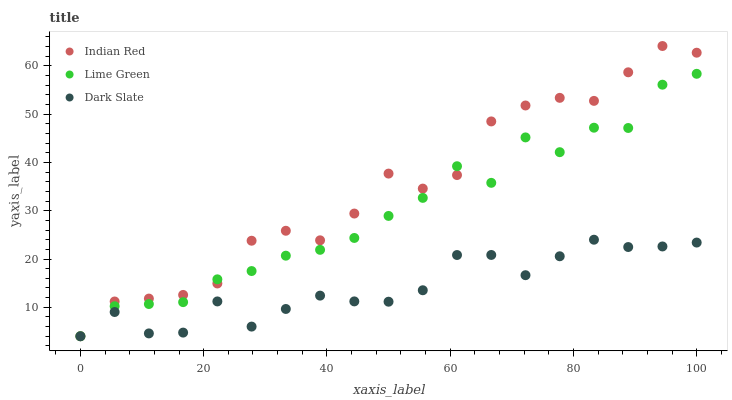Does Dark Slate have the minimum area under the curve?
Answer yes or no. Yes. Does Indian Red have the maximum area under the curve?
Answer yes or no. Yes. Does Lime Green have the minimum area under the curve?
Answer yes or no. No. Does Lime Green have the maximum area under the curve?
Answer yes or no. No. Is Dark Slate the smoothest?
Answer yes or no. Yes. Is Lime Green the roughest?
Answer yes or no. Yes. Is Indian Red the smoothest?
Answer yes or no. No. Is Indian Red the roughest?
Answer yes or no. No. Does Dark Slate have the lowest value?
Answer yes or no. Yes. Does Indian Red have the highest value?
Answer yes or no. Yes. Does Lime Green have the highest value?
Answer yes or no. No. Does Lime Green intersect Indian Red?
Answer yes or no. Yes. Is Lime Green less than Indian Red?
Answer yes or no. No. Is Lime Green greater than Indian Red?
Answer yes or no. No. 